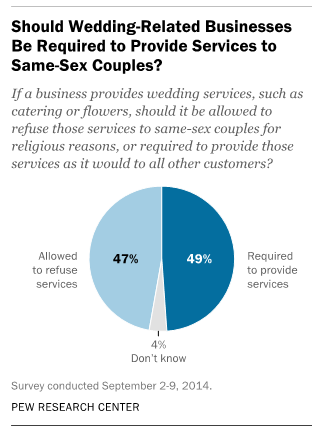Specify some key components in this picture. The percentage value for the 'Don't know' segment is 4%. The average of the two largest segments is 48. 